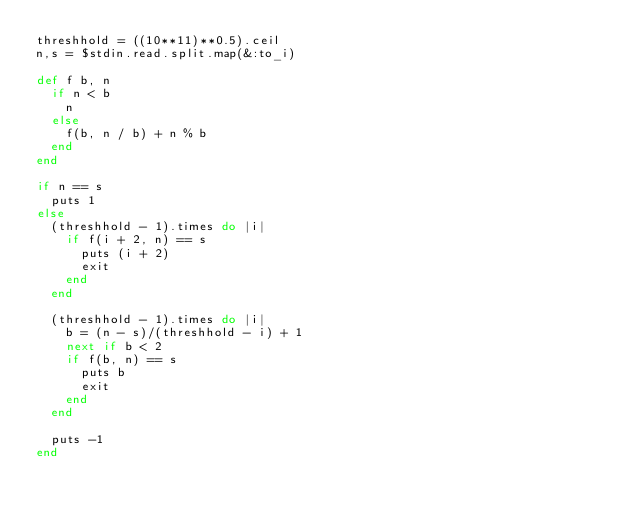Convert code to text. <code><loc_0><loc_0><loc_500><loc_500><_Ruby_>threshhold = ((10**11)**0.5).ceil
n,s = $stdin.read.split.map(&:to_i)

def f b, n
  if n < b
    n
  else
    f(b, n / b) + n % b
  end
end

if n == s
  puts 1
else
  (threshhold - 1).times do |i|
    if f(i + 2, n) == s
      puts (i + 2)
      exit
    end
  end

  (threshhold - 1).times do |i|
    b = (n - s)/(threshhold - i) + 1
    next if b < 2
    if f(b, n) == s
      puts b
      exit
    end
  end

  puts -1
end
</code> 